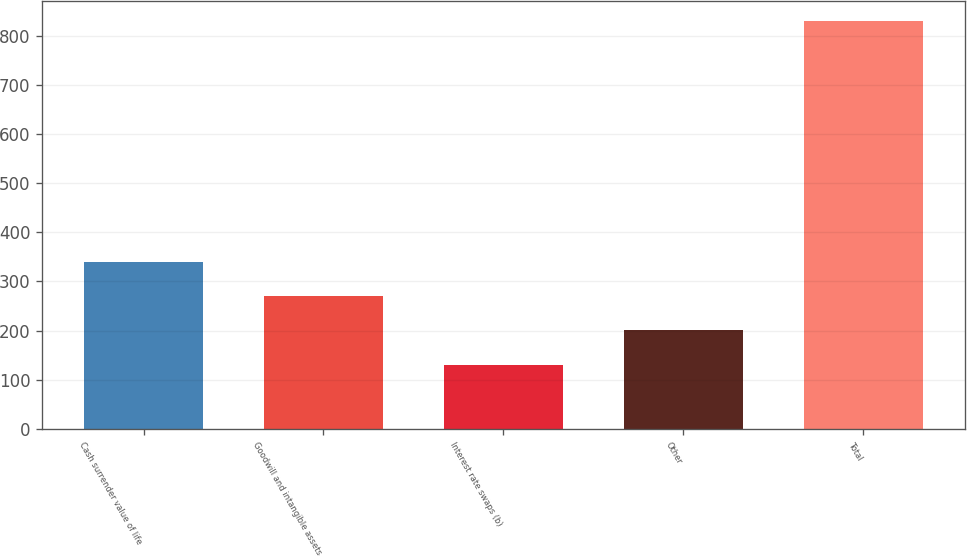Convert chart. <chart><loc_0><loc_0><loc_500><loc_500><bar_chart><fcel>Cash surrender value of life<fcel>Goodwill and intangible assets<fcel>Interest rate swaps (b)<fcel>Other<fcel>Total<nl><fcel>340.4<fcel>270.6<fcel>131<fcel>200.8<fcel>829<nl></chart> 